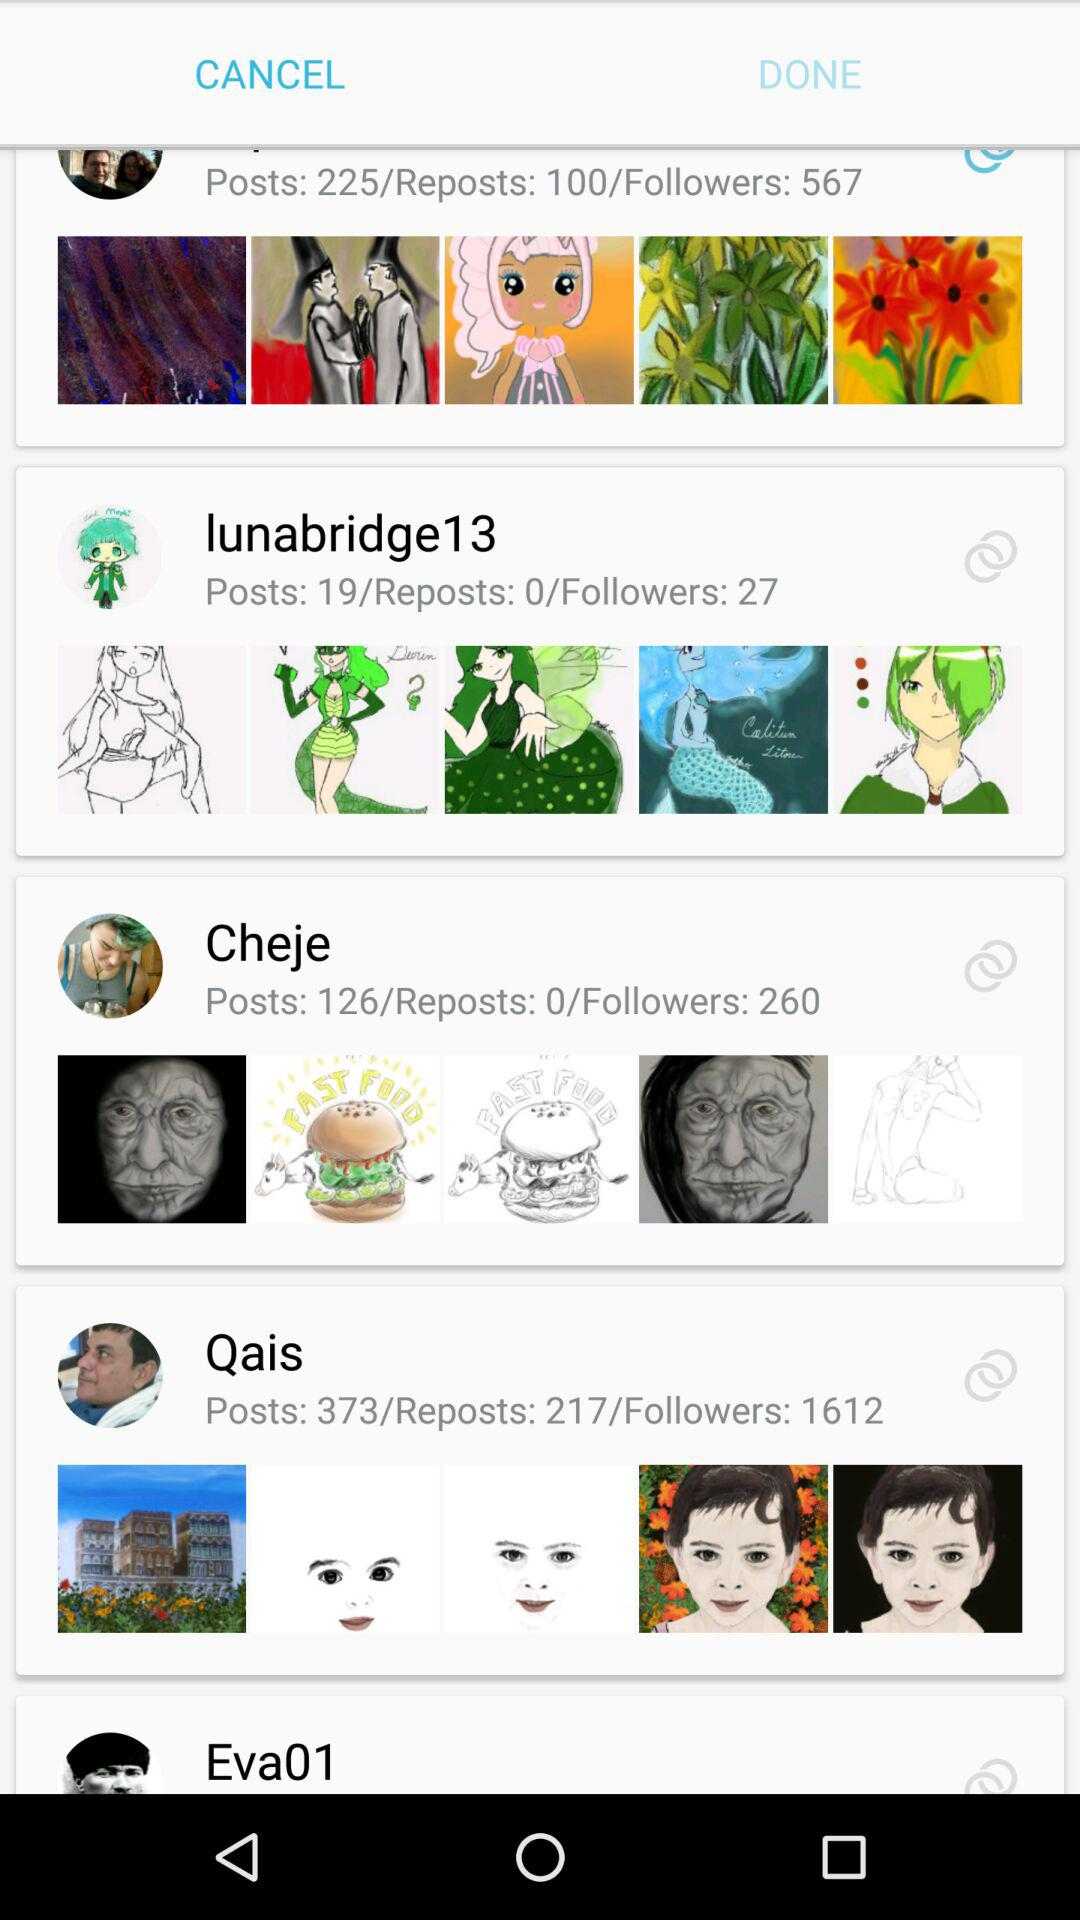How many posts of Cheje? There is 126 posts of Cheje. 